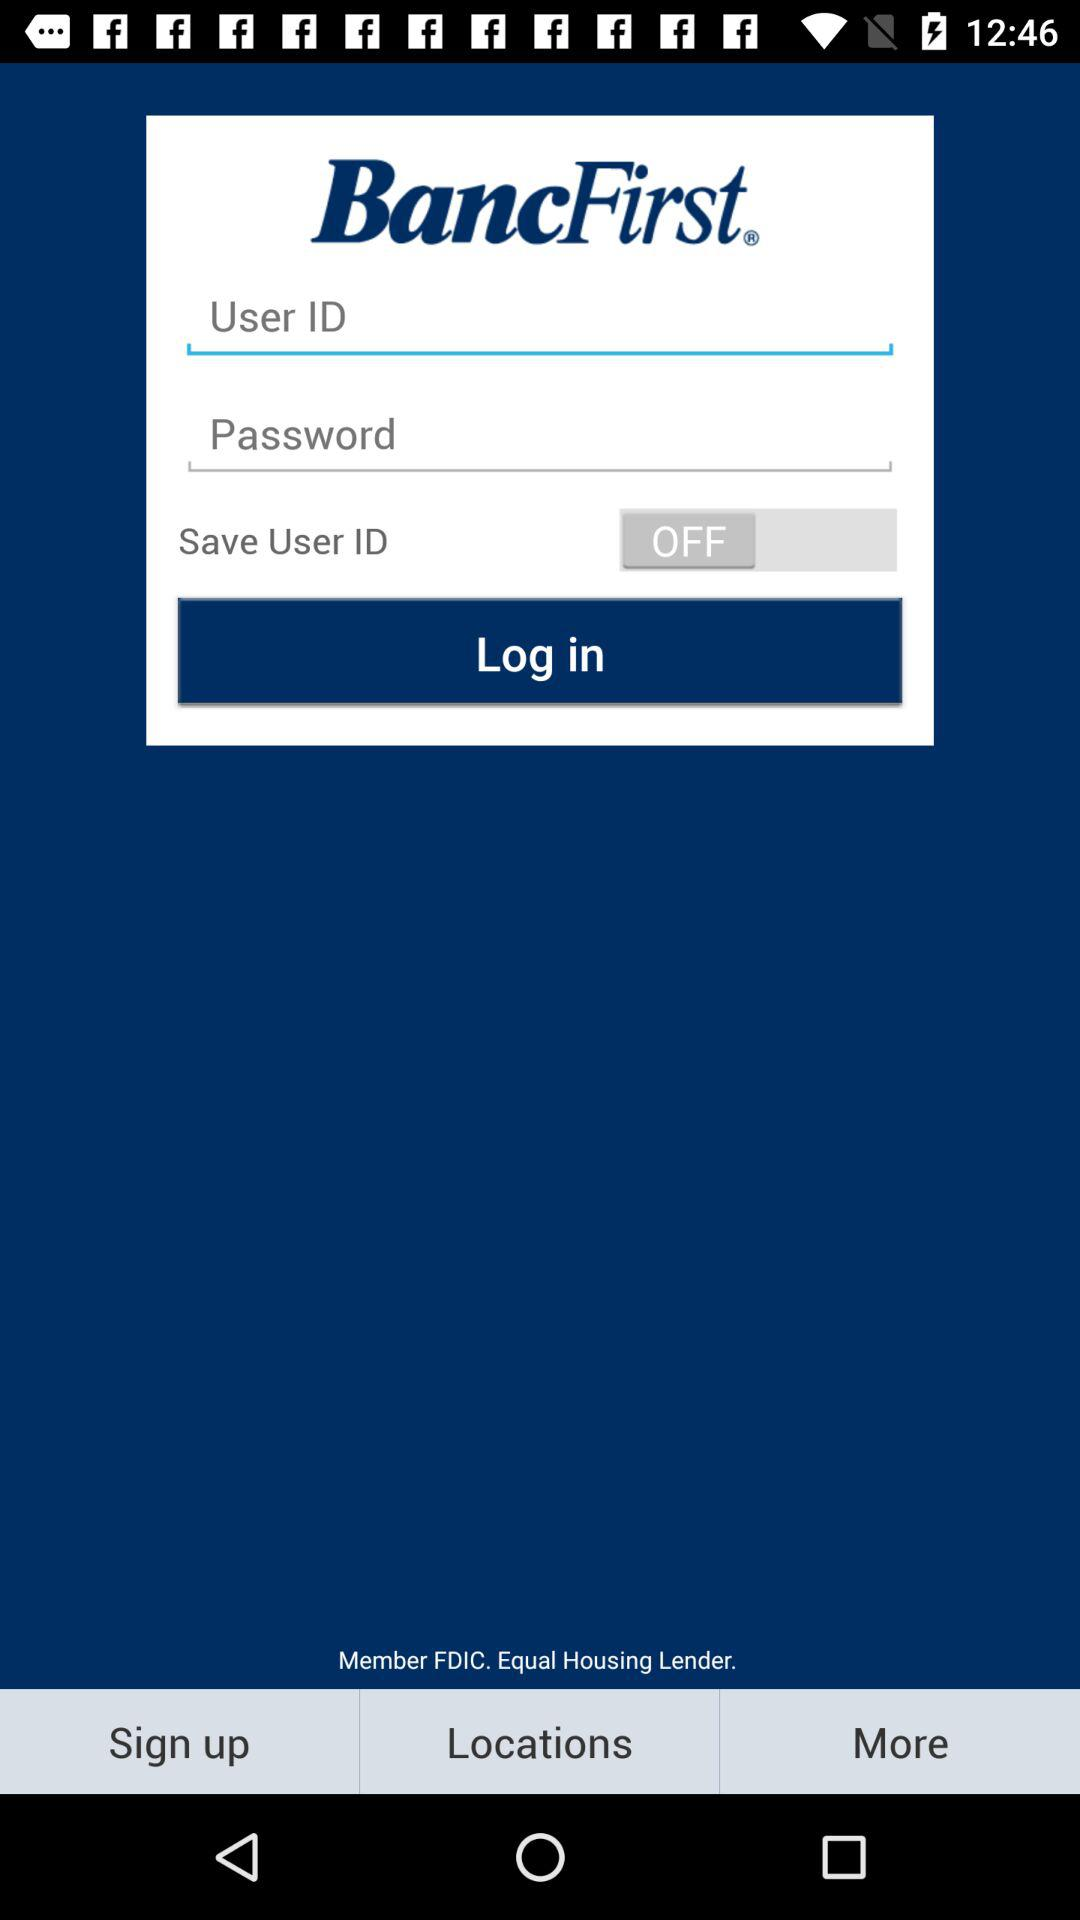What is the name of the application? The name of the application is "BancFirst". 